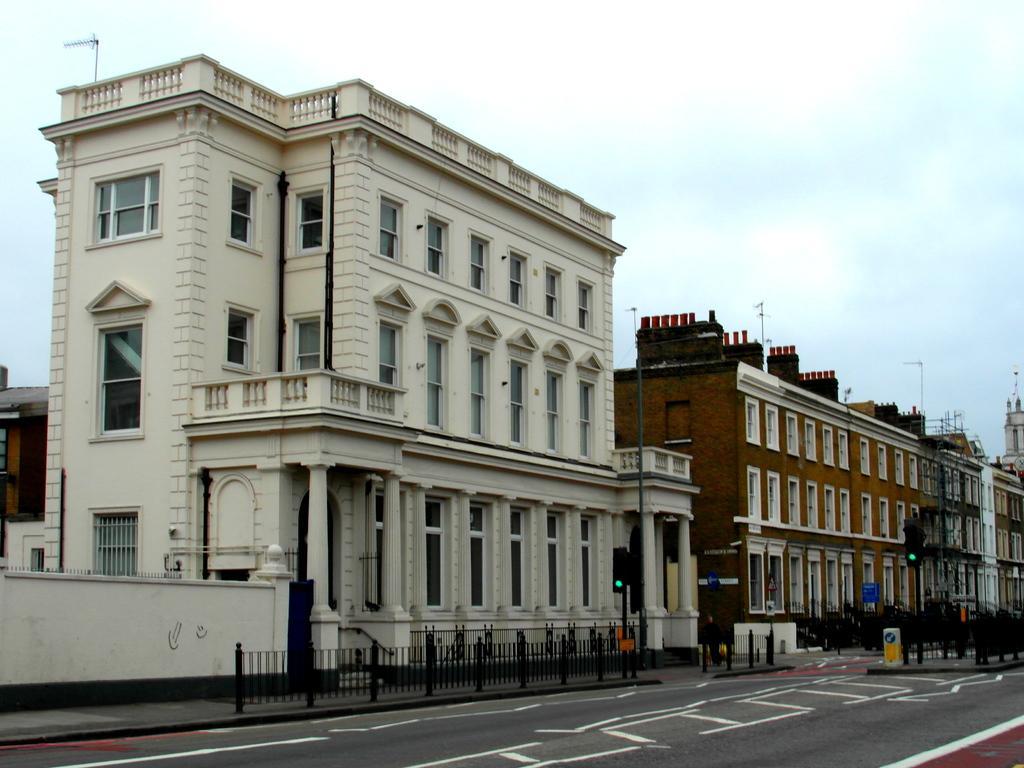In one or two sentences, can you explain what this image depicts? In the picture I can see the road, fence, traffic signal poles, boards, buildings and the sky in the background. 